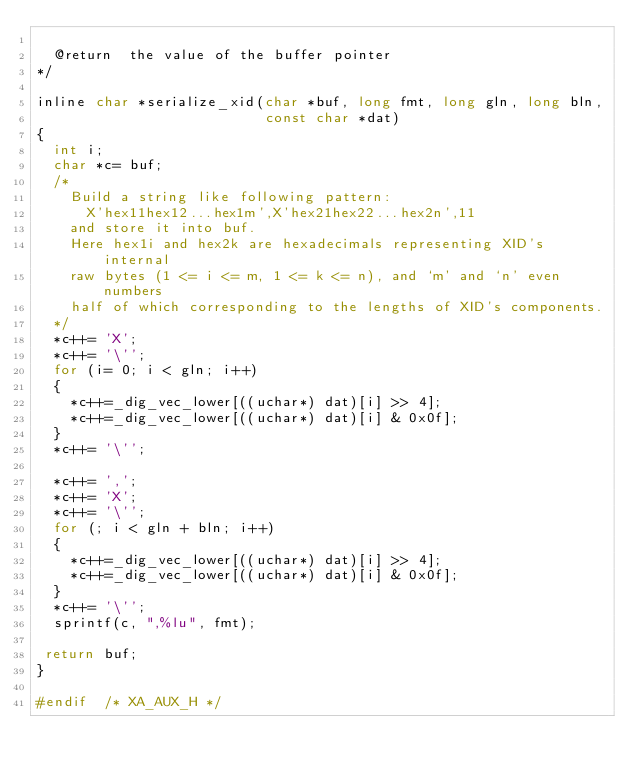<code> <loc_0><loc_0><loc_500><loc_500><_C_>
  @return  the value of the buffer pointer
*/

inline char *serialize_xid(char *buf, long fmt, long gln, long bln,
                           const char *dat)
{
  int i;
  char *c= buf;
  /*
    Build a string like following pattern:
      X'hex11hex12...hex1m',X'hex21hex22...hex2n',11
    and store it into buf.
    Here hex1i and hex2k are hexadecimals representing XID's internal
    raw bytes (1 <= i <= m, 1 <= k <= n), and `m' and `n' even numbers
    half of which corresponding to the lengths of XID's components.
  */
  *c++= 'X';
  *c++= '\'';
  for (i= 0; i < gln; i++)
  {
    *c++=_dig_vec_lower[((uchar*) dat)[i] >> 4];
    *c++=_dig_vec_lower[((uchar*) dat)[i] & 0x0f];
  }
  *c++= '\'';

  *c++= ',';
  *c++= 'X';
  *c++= '\'';
  for (; i < gln + bln; i++)
  {
    *c++=_dig_vec_lower[((uchar*) dat)[i] >> 4];
    *c++=_dig_vec_lower[((uchar*) dat)[i] & 0x0f];
  }
  *c++= '\'';
  sprintf(c, ",%lu", fmt);

 return buf;
}

#endif	/* XA_AUX_H */
 </code> 